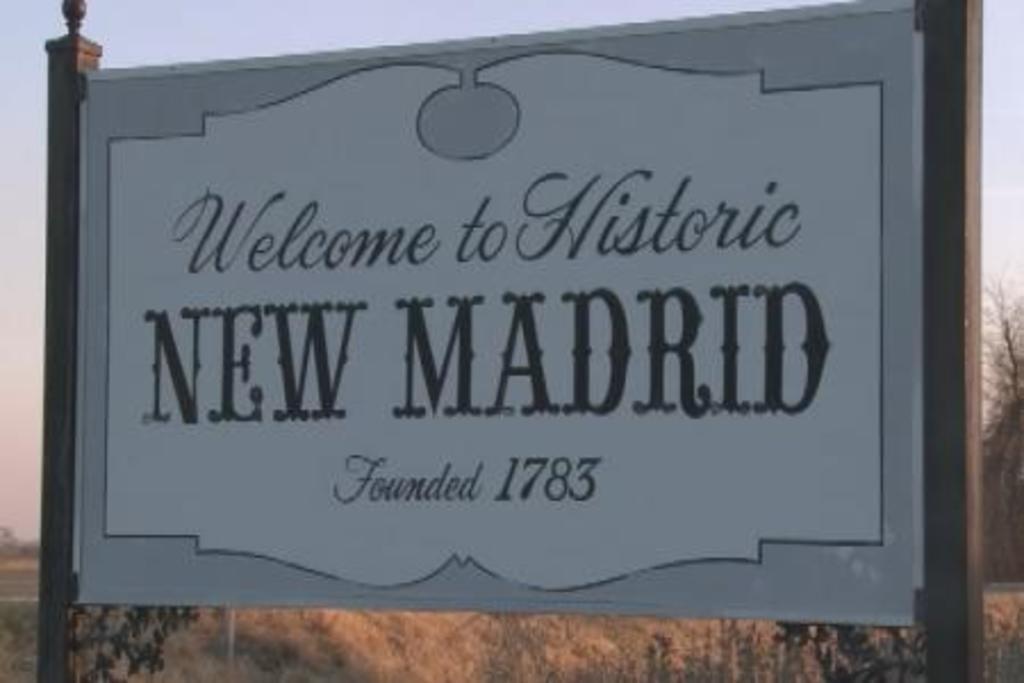When was new madrid founded?
Your answer should be compact. 1783. What town is this?
Offer a very short reply. New madrid. 